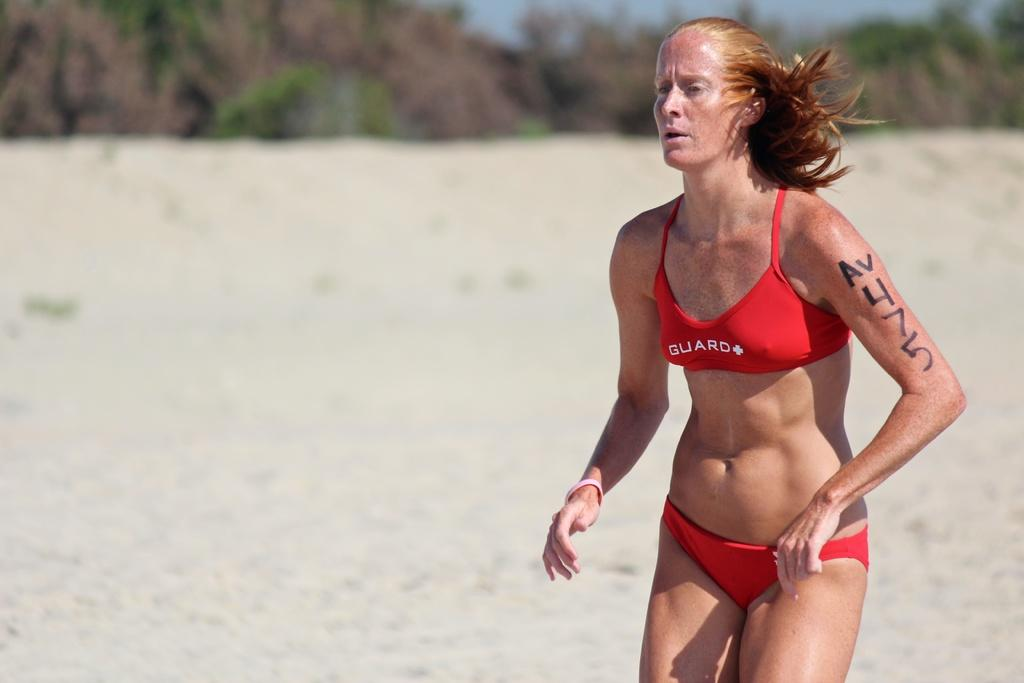<image>
Present a compact description of the photo's key features. a women running with 475 written on the person's arm 